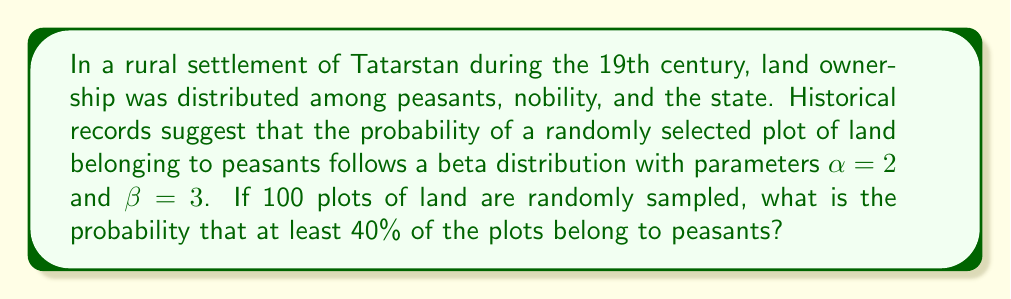Teach me how to tackle this problem. To solve this problem, we need to follow these steps:

1) First, recall that the beta distribution with parameters $\alpha$ and $\beta$ has a mean of:

   $$\mu = \frac{\alpha}{\alpha + \beta}$$

2) In this case, $\alpha = 2$ and $\beta = 3$, so the mean is:

   $$\mu = \frac{2}{2 + 3} = \frac{2}{5} = 0.4$$

3) This means that on average, 40% of the land belongs to peasants.

4) Now, we need to find the probability that in a sample of 100 plots, at least 40 belong to peasants.

5) This scenario follows a binomial distribution, where each plot has a probability of 0.4 of belonging to peasants, and we're looking for the probability of 40 or more successes out of 100 trials.

6) The probability mass function of the binomial distribution is:

   $$P(X = k) = \binom{n}{k} p^k (1-p)^{n-k}$$

   where $n$ is the number of trials, $k$ is the number of successes, and $p$ is the probability of success on each trial.

7) We need to sum this for all $k$ from 40 to 100:

   $$P(X \geq 40) = \sum_{k=40}^{100} \binom{100}{k} (0.4)^k (0.6)^{100-k}$$

8) This sum is computationally intensive, so we typically use statistical software or tables to calculate it.

9) Using a statistical calculator or software, we find that:

   $$P(X \geq 40) \approx 0.5244$$

Therefore, the probability that at least 40% of the 100 sampled plots belong to peasants is approximately 0.5244 or 52.44%.
Answer: 0.5244 or 52.44% 